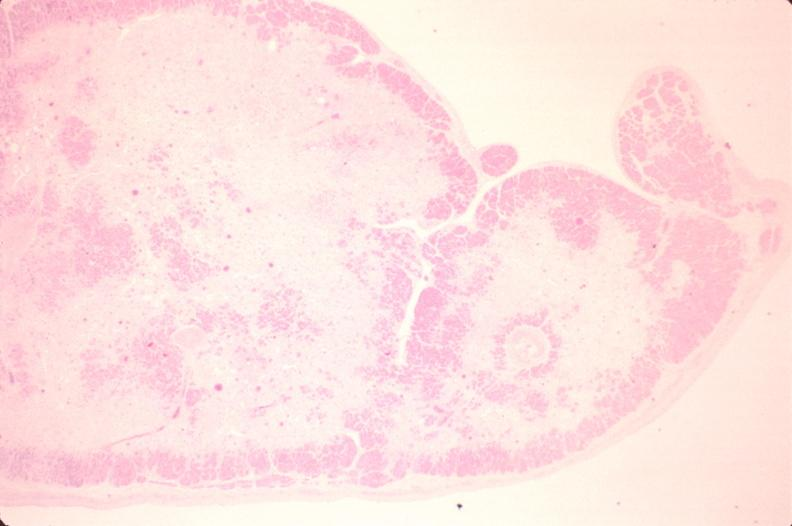does lesion of myocytolysis show heart, papillary muscle, fibrosis, chronic ischemic heart disease?
Answer the question using a single word or phrase. No 